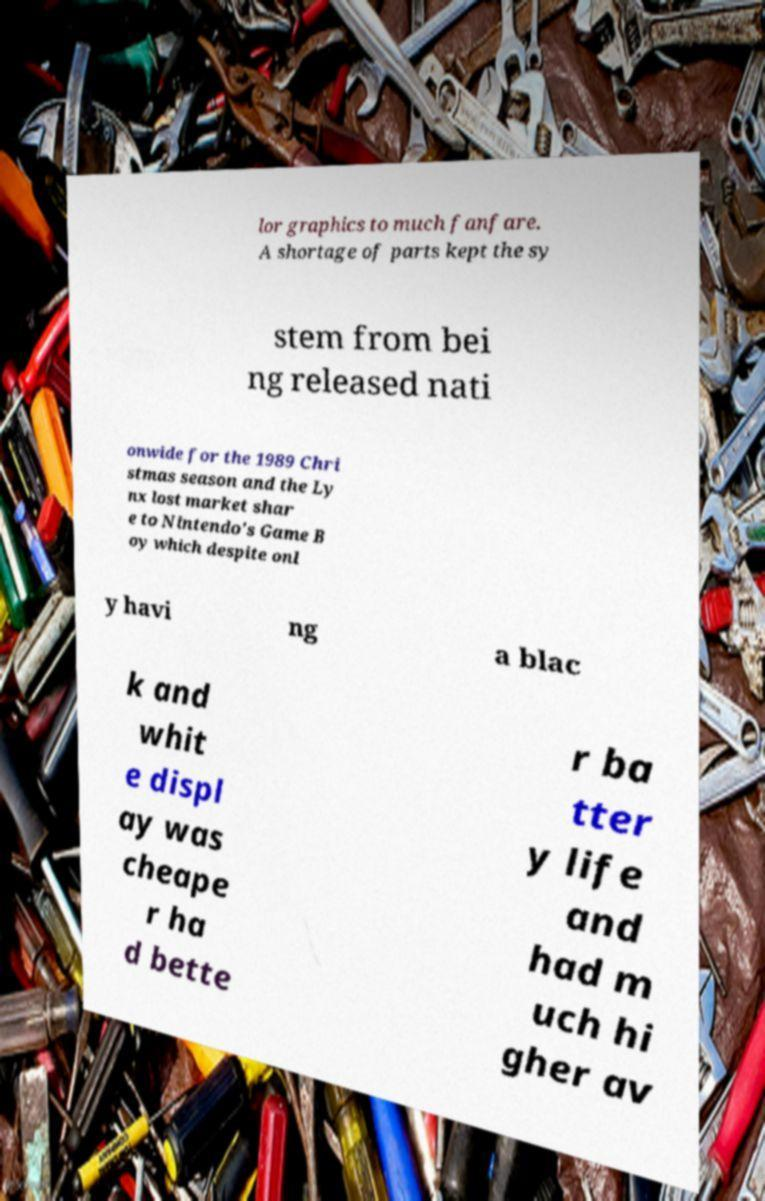Please identify and transcribe the text found in this image. lor graphics to much fanfare. A shortage of parts kept the sy stem from bei ng released nati onwide for the 1989 Chri stmas season and the Ly nx lost market shar e to Nintendo's Game B oy which despite onl y havi ng a blac k and whit e displ ay was cheape r ha d bette r ba tter y life and had m uch hi gher av 